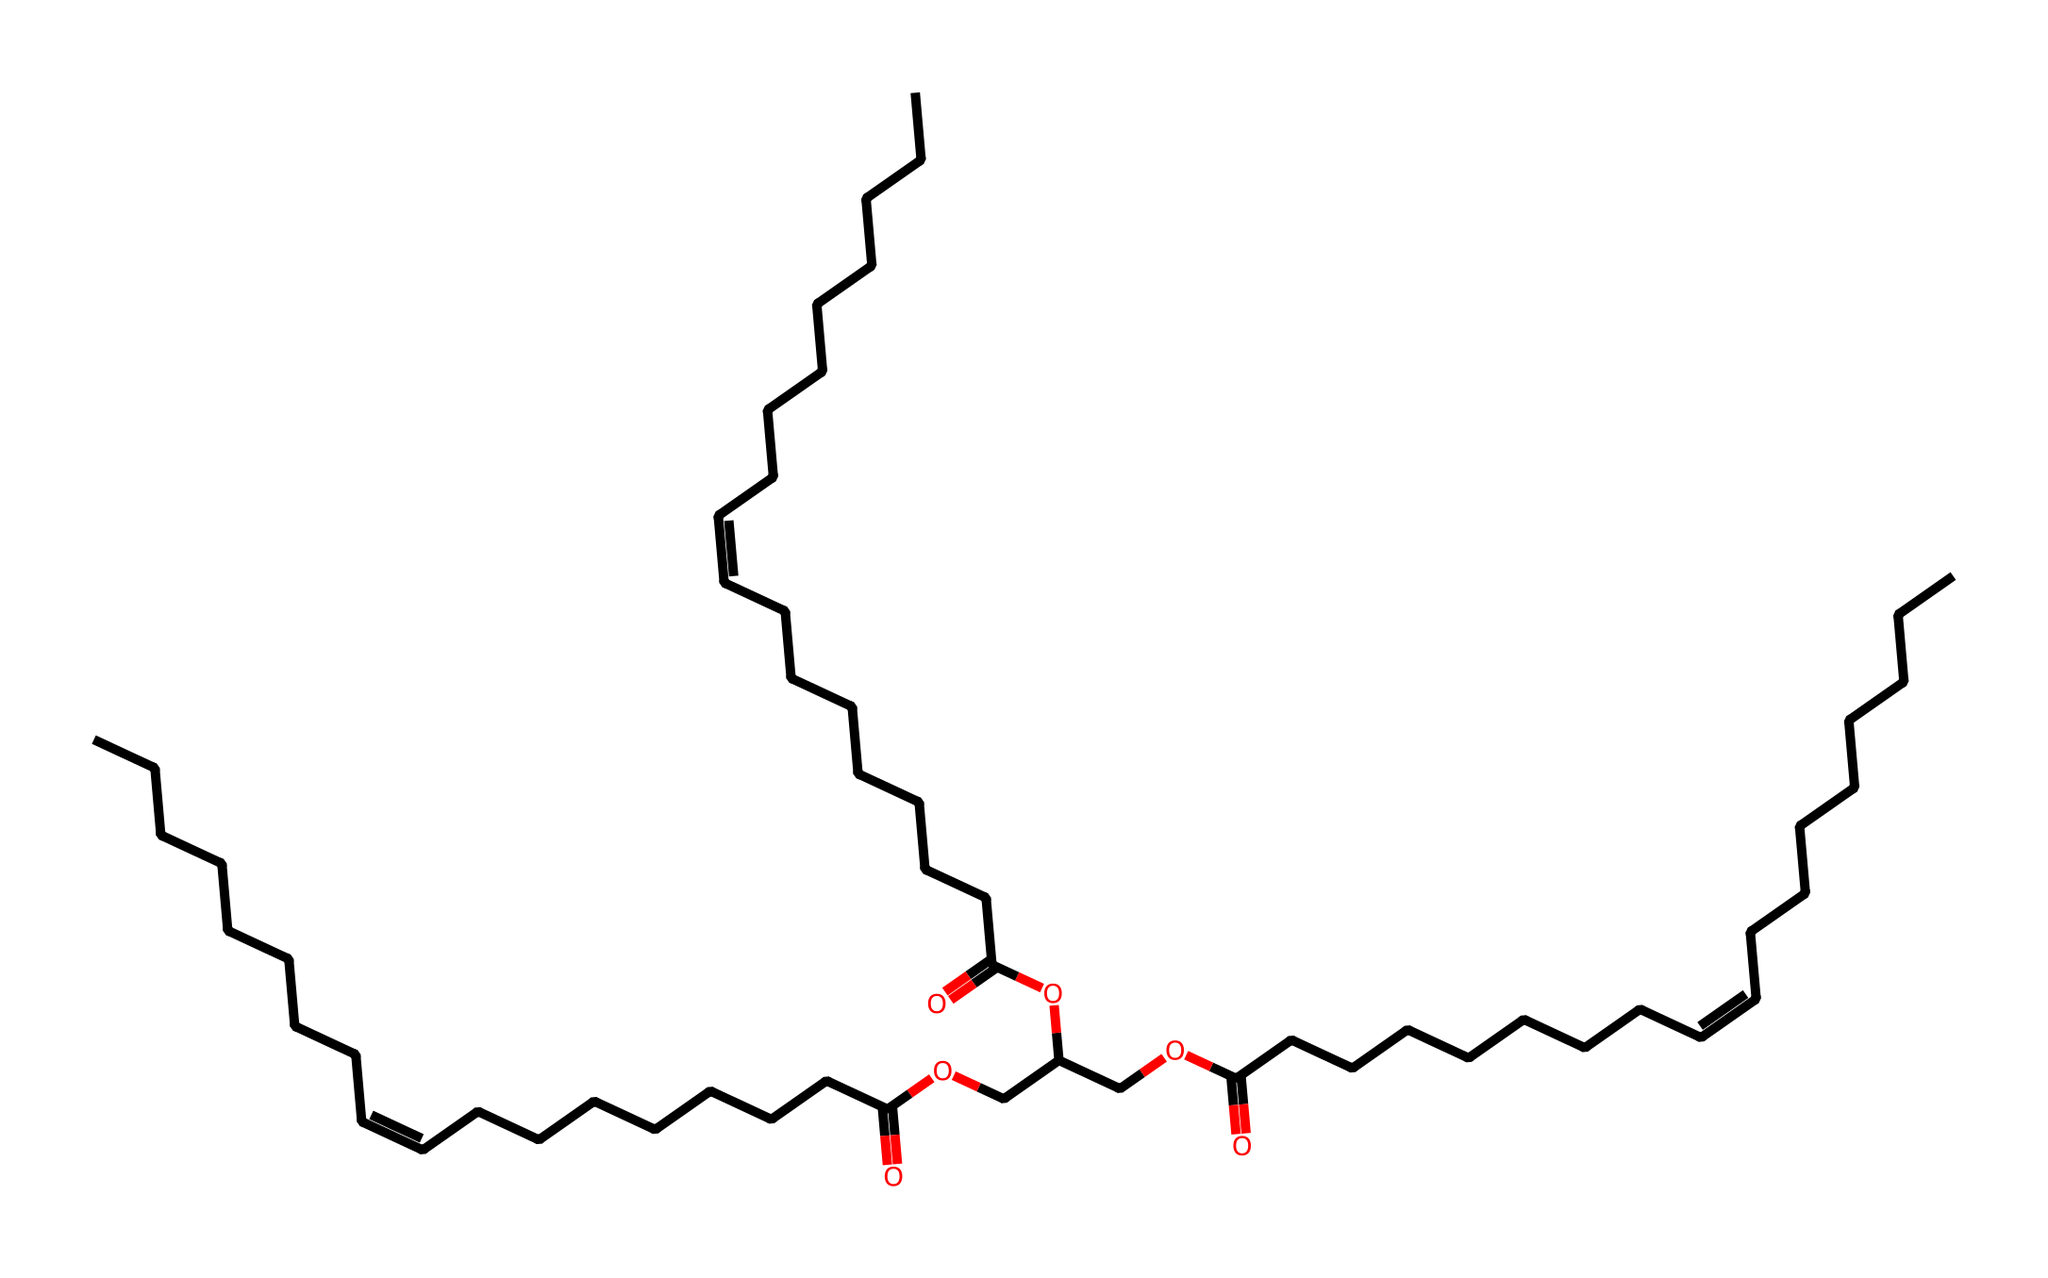What is the main functional group present in this chemical? The main functional group can be identified by looking for characteristic groups in the structure. In this case, the presence of the -COOH group indicates a carboxylic acid.
Answer: carboxylic acid How many carbon atoms are present in this molecule? By carefully counting the carbon atoms visible in the structure, including those in the long hydrocarbon chains and the branches, there are a total of 36 carbon atoms.
Answer: 36 What type of unsaturation is present in the chemical structure? Observing the double bonds indicated in the SMILES representation ("/C=C\"), it is clear that there are alkene functionalities present, which means that this chemical contains unsaturation.
Answer: alkene What is the total number of oxygen atoms in this compound? By counting the oxygen atoms in both the carboxylic acid groups and the ester linkages present in the structure, a total of 6 oxygen atoms can be identified.
Answer: 6 Is this lubricant likely to be biodegradable? The presence of ester and carboxylic acid groups in the structure suggests that this compound is designed for biodegradability, which supports its classification as eco-friendly.
Answer: yes How many ester linkages are in the molecule? By analyzing the structure and identifying the ester functionalities (the -COO- groups), it can be determined that there are 3 distinct ester linkages present within the molecule.
Answer: 3 What type of component is this chemical most likely intended for in film equipment? The chemical structure suggests excellent lubrication properties due to its long hydrocarbon chains and functional groups, which are suitable for reducing friction in mechanical components of film equipment.
Answer: lubricant 